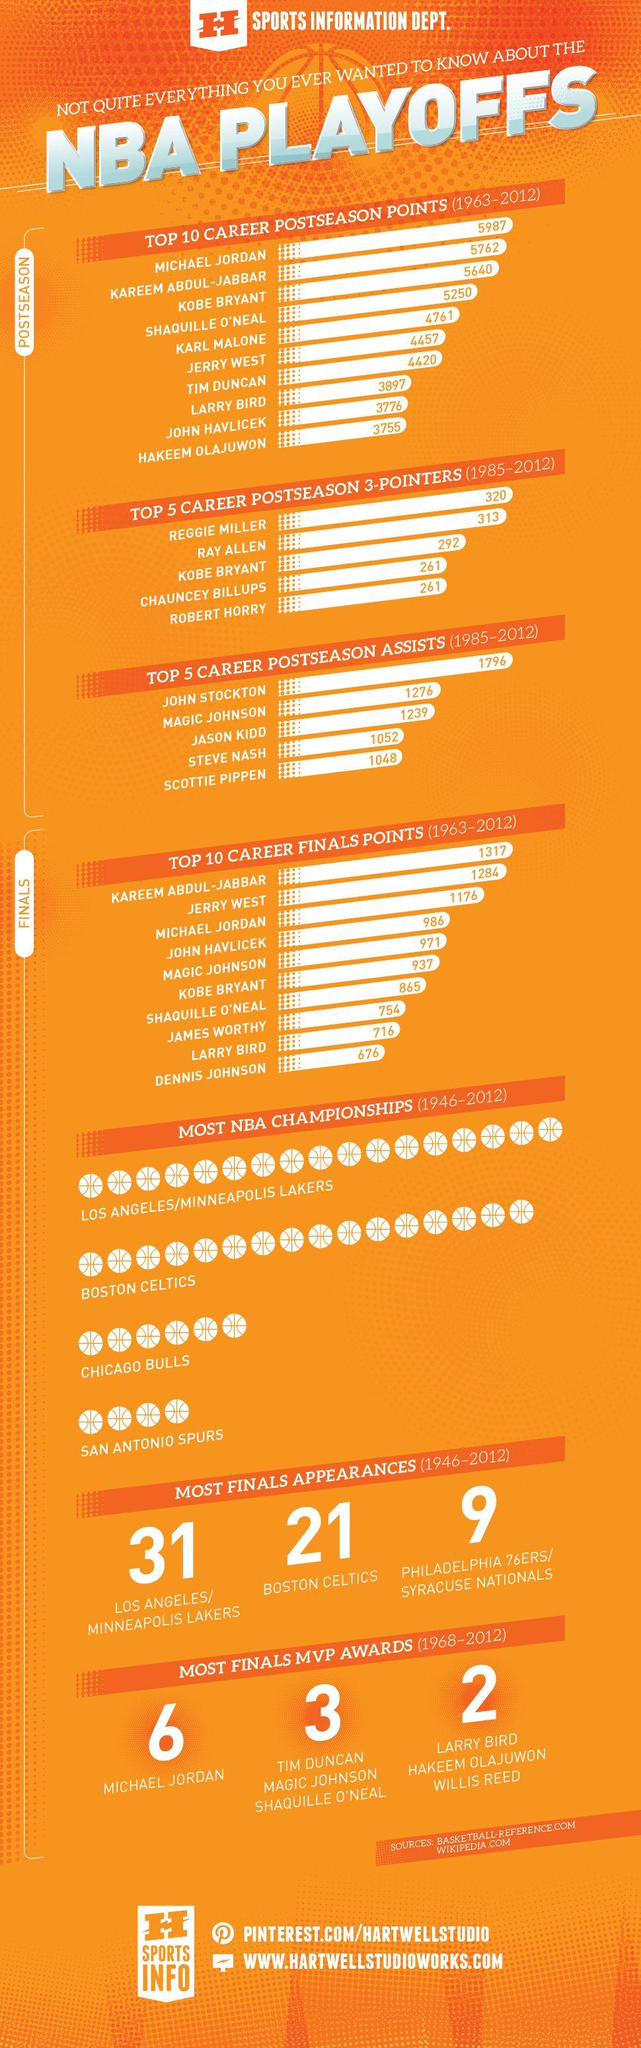Give some essential details in this illustration. Jerry West scored more postseason points than Tim Duncan, with a total of 37. In the postseason, Michael Jordan scored the highest number of points, achieving 5,987 points. Chicago Bulls have won the third highest number of NBA championships. In the postseason, Kobe Bryant scored more points than Tim Duncan. The Boston Celtics have made 21 appearances in the finals. 